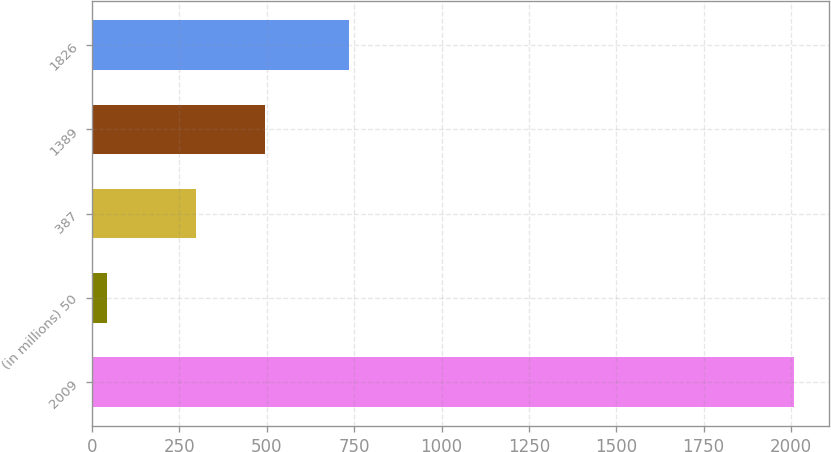Convert chart to OTSL. <chart><loc_0><loc_0><loc_500><loc_500><bar_chart><fcel>2009<fcel>(in millions) 50<fcel>387<fcel>1389<fcel>1826<nl><fcel>2008<fcel>44<fcel>298<fcel>494.4<fcel>734<nl></chart> 